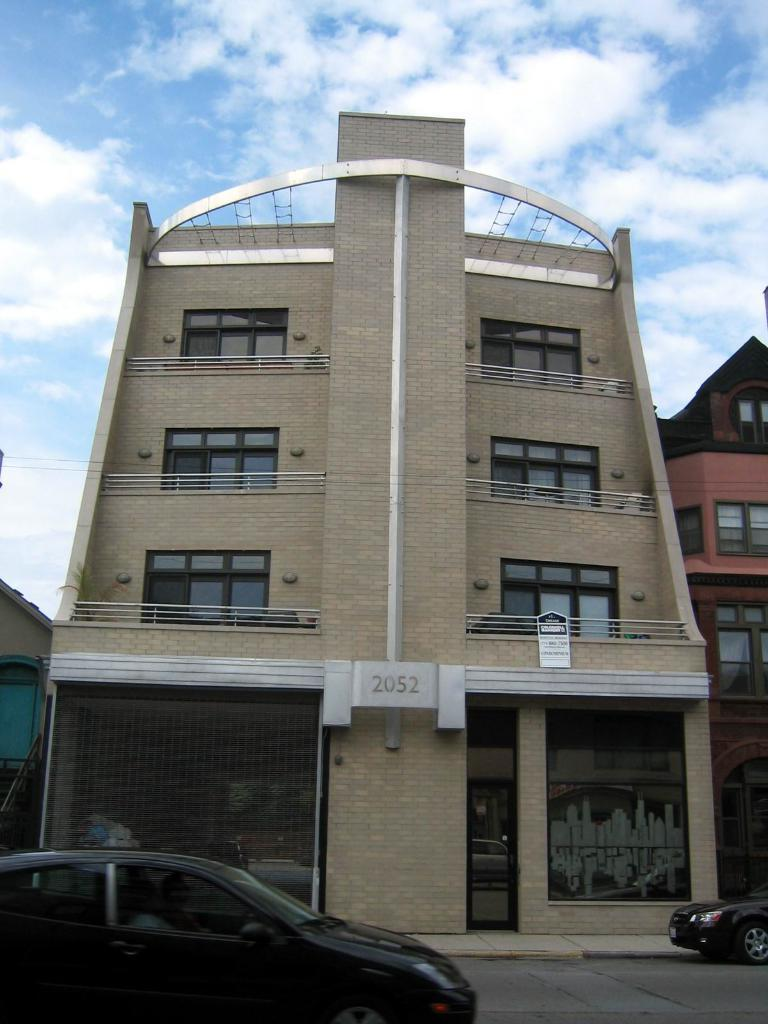What type of vehicles can be seen on the road in the image? There are cars on the road in the image. What structures are present in the image? There are buildings in the image. What object can be seen in the image that might be used for displaying information or advertisements? There is a board in the image. What type of plants are visible in the image? There are house plants in the image. What is visible in the background of the image? The sky is visible in the background of the image. What can be observed in the sky in the image? There are clouds in the sky. How many ladybugs can be seen crawling on the board in the image? There are no ladybugs present in the image. What type of badge is the porter wearing in the image? There is no porter or badge present in the image. 